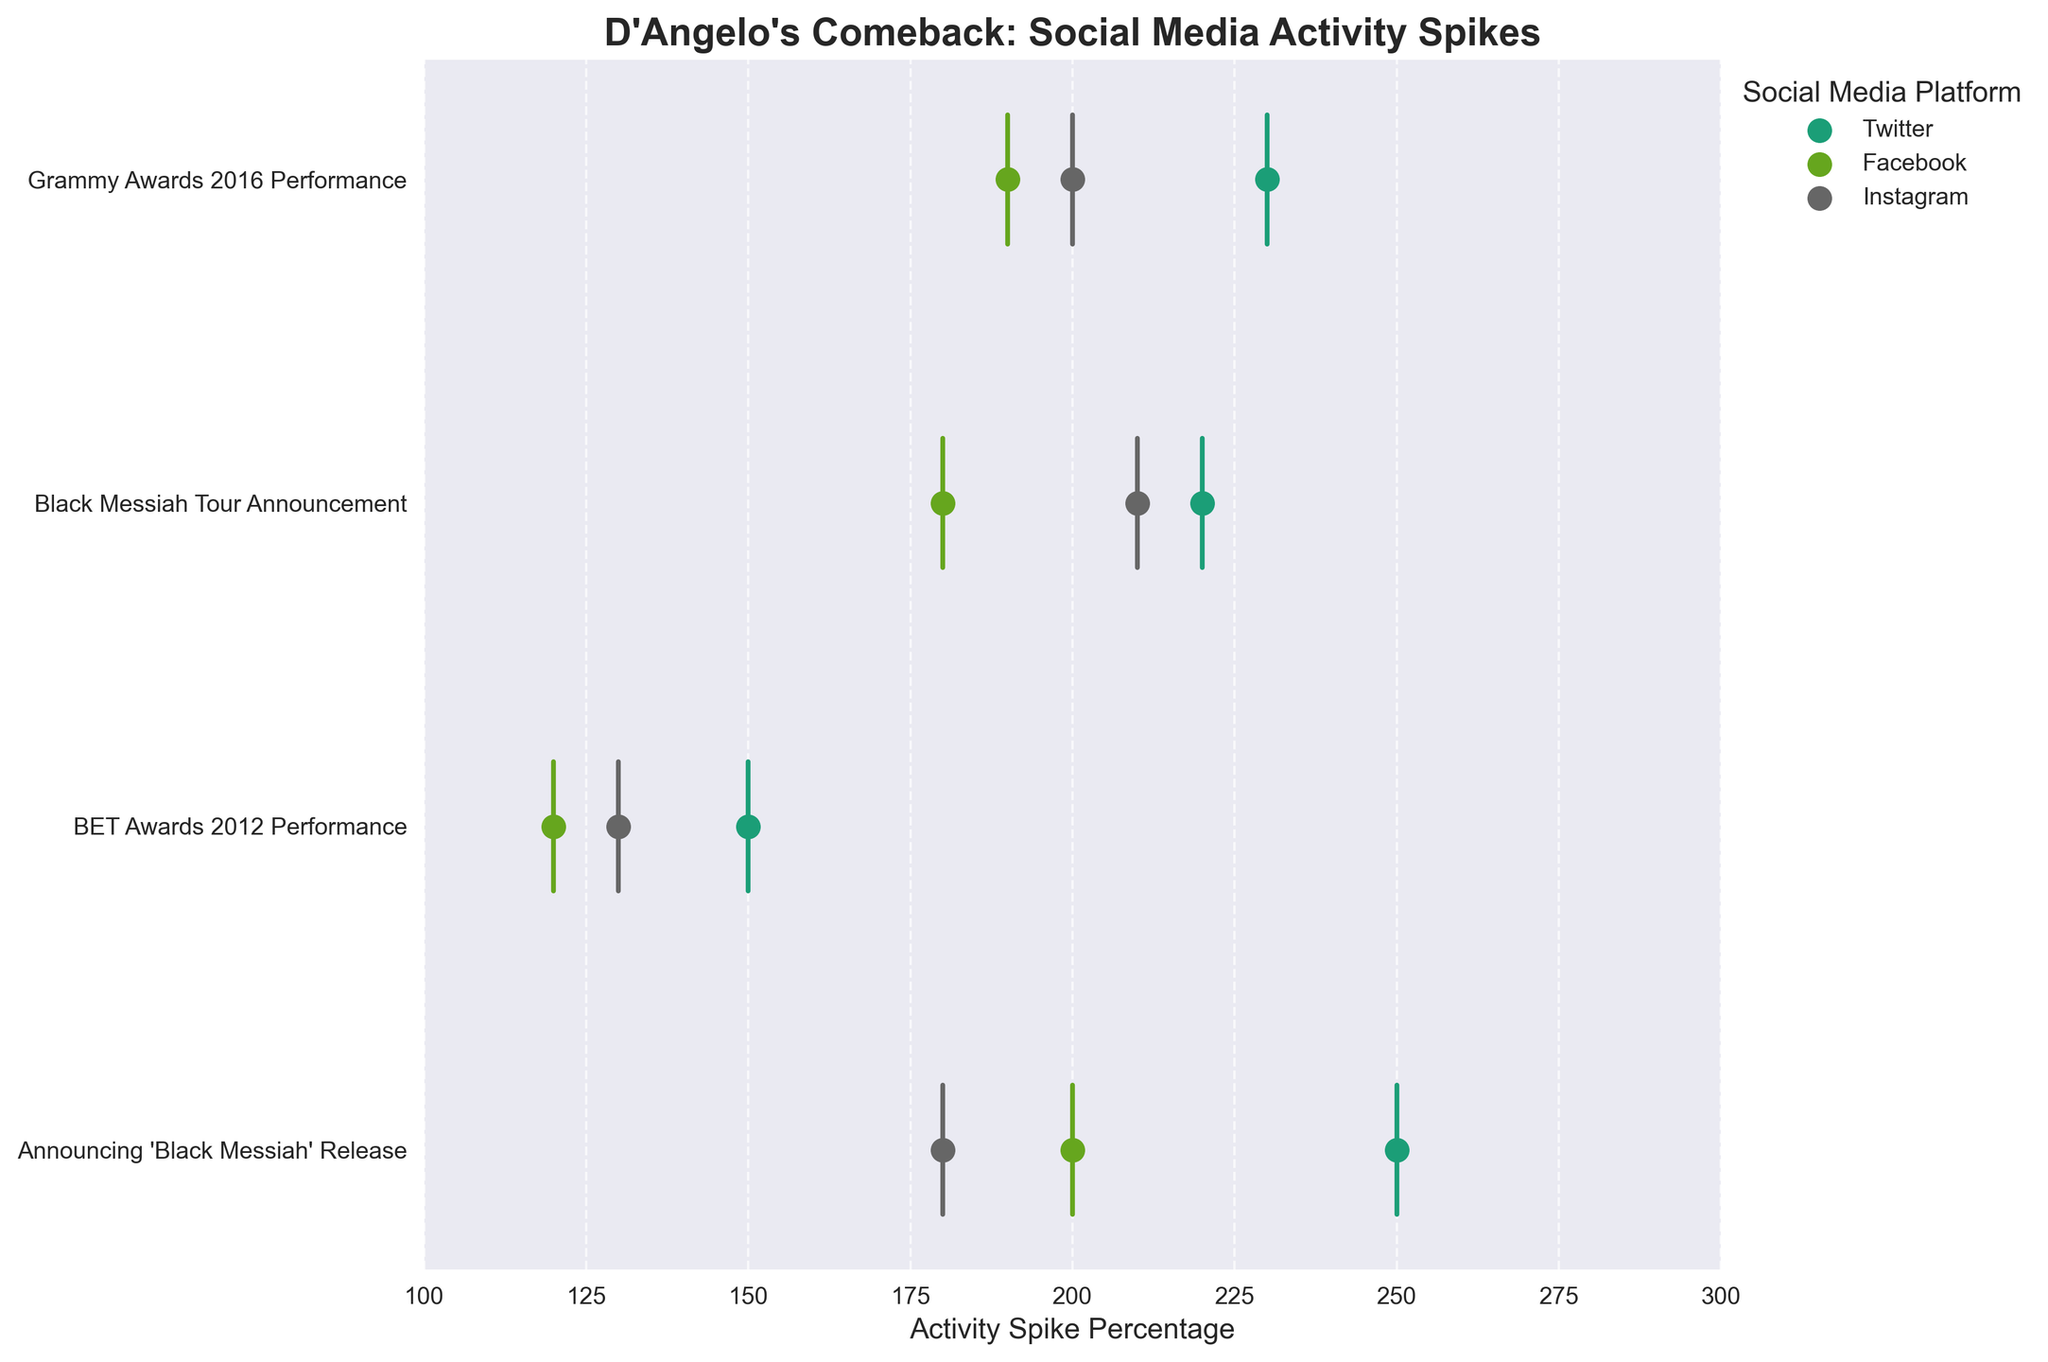What is the title of the plot? The title of the plot is shown at the top, and it summarizes the main topic of the visual representation. In this case, it states, "D'Angelo's Comeback: Social Media Activity Spikes." The title helps viewers quickly understand the subject of the plot.
Answer: "D'Angelo's Comeback: Social Media Activity Spikes" Which event had the highest activity spike percentage on Twitter? Look at the scatter points on the plot for Twitter. The event with the dot furthest to the right represents the highest activity spike. In this case, "Announcing 'Black Messiah' Release" had the highest spike at 250%.
Answer: "Announcing 'Black Messiah' Release" Compare the activity spike percentages between Instagram and Facebook for the "Black Messiah Tour Announcement." Which platform had a higher spike? Examine the points on the plot for each platform related to the specific event. For "Black Messiah Tour Announcement," Instagram had a spike of 210% whereas Facebook had a spike of 180%. Instagram had the higher spike.
Answer: Instagram What was the social media platform with the smallest activity spike percentage, and which event is it associated with? Look for the lowest percentage value on the x-axis across all platforms and events. The smallest spike percentage is 120% on Facebook related to the "BET Awards 2012 Performance" event.
Answer: Facebook, "BET Awards 2012 Performance" What is the average activity spike percentage for Instagram across all events? Gather the activity spike percentages for Instagram: 180%, 130%, 210%, 200%. Calculate the average: (180 + 130 + 210 + 200) / 4 = 720 / 4 = 180.
Answer: 180 Did any event have the same activity spike percentage across multiple platforms? Compare the spike percentages for different platforms within each event. None of the events have the same spike percentage across multiple platforms.
Answer: No How does the spike for "Grammy Awards 2016 Performance" on Twitter compare to "Black Messiah Tour Announcement" on Twitter? Find the spikes for both events on Twitter. "Grammy Awards 2016 Performance" had a 230% spike, while "Black Messiah Tour Announcement" had a 220% spike. "Grammy Awards 2016 Performance" was higher.
Answer: "Grammy Awards 2016 Performance" is higher Which event showed the most uniform spike percentages across different platforms, and what are the values? Look for the event where the spike percentages across Twitter, Facebook, and Instagram are closest to each other. "Grammy Awards 2016 Performance" shows the most uniformity with values 230% (Twitter), 190% (Facebook), and 200% (Instagram).
Answer: "Grammy Awards 2016 Performance", 230% (Twitter), 190% (Facebook), 200% (Instagram) For the "Announcing 'Black Messiah' Release" event, what is the range of activity spike percentages across all platforms? Find the highest and lowest spike percentages for this event: Twitter (250%), Facebook (200%), and Instagram (180%). The range is calculated as 250% - 180% = 70%.
Answer: 70% 